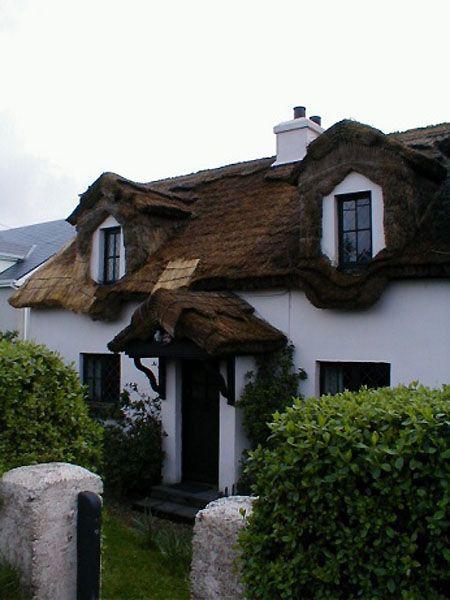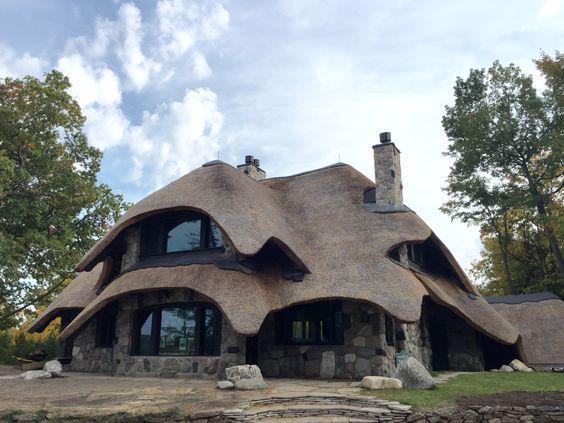The first image is the image on the left, the second image is the image on the right. Considering the images on both sides, is "A building with a shaggy thatched roof topped with a notched border has two projecting dormer windows and stone columns at the entrance to the property." valid? Answer yes or no. Yes. The first image is the image on the left, the second image is the image on the right. Assess this claim about the two images: "A fence runs around the house in the image on the right.". Correct or not? Answer yes or no. No. 